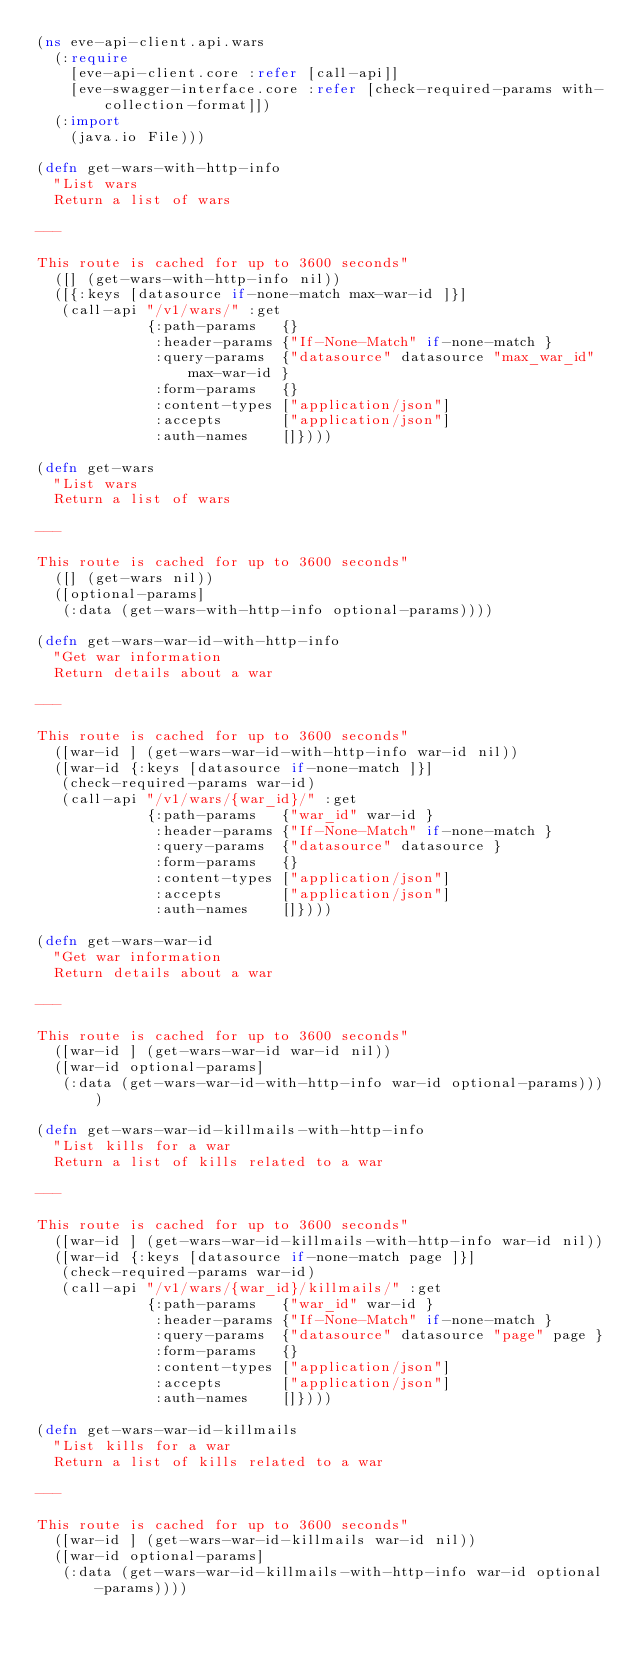Convert code to text. <code><loc_0><loc_0><loc_500><loc_500><_Clojure_>(ns eve-api-client.api.wars
  (:require
    [eve-api-client.core :refer [call-api]]
    [eve-swagger-interface.core :refer [check-required-params with-collection-format]])
  (:import
    (java.io File)))

(defn get-wars-with-http-info
  "List wars
  Return a list of wars

---

This route is cached for up to 3600 seconds"
  ([] (get-wars-with-http-info nil))
  ([{:keys [datasource if-none-match max-war-id ]}]
   (call-api "/v1/wars/" :get
             {:path-params   {}
              :header-params {"If-None-Match" if-none-match }
              :query-params  {"datasource" datasource "max_war_id" max-war-id }
              :form-params   {}
              :content-types ["application/json"]
              :accepts       ["application/json"]
              :auth-names    []})))

(defn get-wars
  "List wars
  Return a list of wars

---

This route is cached for up to 3600 seconds"
  ([] (get-wars nil))
  ([optional-params]
   (:data (get-wars-with-http-info optional-params))))

(defn get-wars-war-id-with-http-info
  "Get war information
  Return details about a war

---

This route is cached for up to 3600 seconds"
  ([war-id ] (get-wars-war-id-with-http-info war-id nil))
  ([war-id {:keys [datasource if-none-match ]}]
   (check-required-params war-id)
   (call-api "/v1/wars/{war_id}/" :get
             {:path-params   {"war_id" war-id }
              :header-params {"If-None-Match" if-none-match }
              :query-params  {"datasource" datasource }
              :form-params   {}
              :content-types ["application/json"]
              :accepts       ["application/json"]
              :auth-names    []})))

(defn get-wars-war-id
  "Get war information
  Return details about a war

---

This route is cached for up to 3600 seconds"
  ([war-id ] (get-wars-war-id war-id nil))
  ([war-id optional-params]
   (:data (get-wars-war-id-with-http-info war-id optional-params))))

(defn get-wars-war-id-killmails-with-http-info
  "List kills for a war
  Return a list of kills related to a war

---

This route is cached for up to 3600 seconds"
  ([war-id ] (get-wars-war-id-killmails-with-http-info war-id nil))
  ([war-id {:keys [datasource if-none-match page ]}]
   (check-required-params war-id)
   (call-api "/v1/wars/{war_id}/killmails/" :get
             {:path-params   {"war_id" war-id }
              :header-params {"If-None-Match" if-none-match }
              :query-params  {"datasource" datasource "page" page }
              :form-params   {}
              :content-types ["application/json"]
              :accepts       ["application/json"]
              :auth-names    []})))

(defn get-wars-war-id-killmails
  "List kills for a war
  Return a list of kills related to a war

---

This route is cached for up to 3600 seconds"
  ([war-id ] (get-wars-war-id-killmails war-id nil))
  ([war-id optional-params]
   (:data (get-wars-war-id-killmails-with-http-info war-id optional-params))))

</code> 